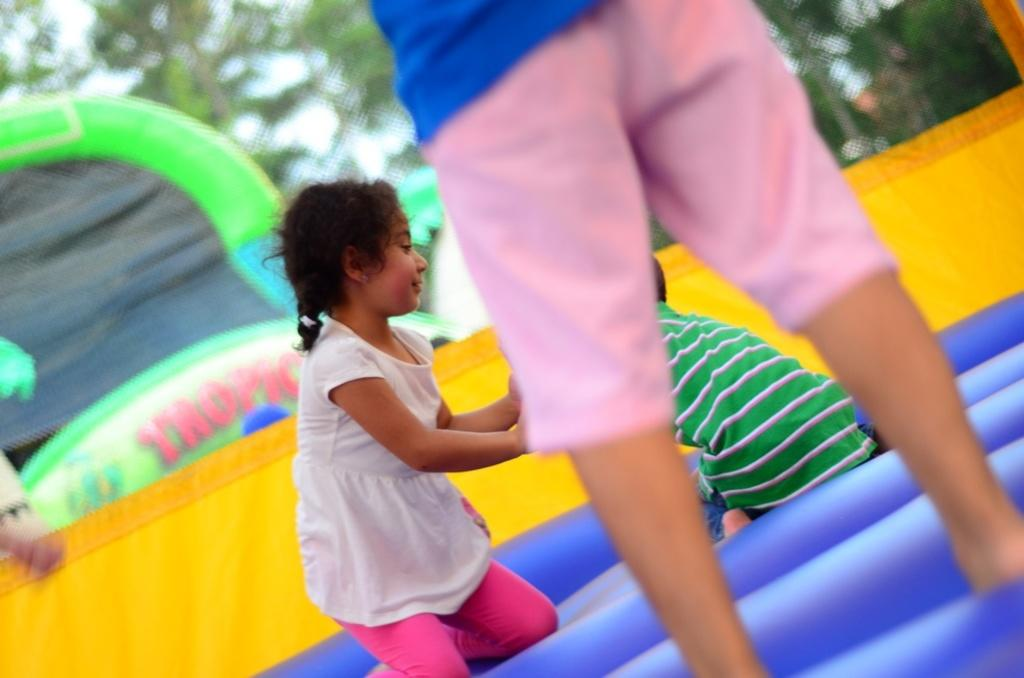What is happening in the image involving a group of people? The people in the image are playing on an inflatable object. What can be seen in the background of the image? There are trees visible in the background of the image. What type of industry can be seen in the image? There is no industry present in the image; it features a group of people playing on an inflatable object with trees in the background. How does the cough affect the people in the image? There is no mention of a cough or any health issues in the image; it simply shows people playing on an inflatable object. 